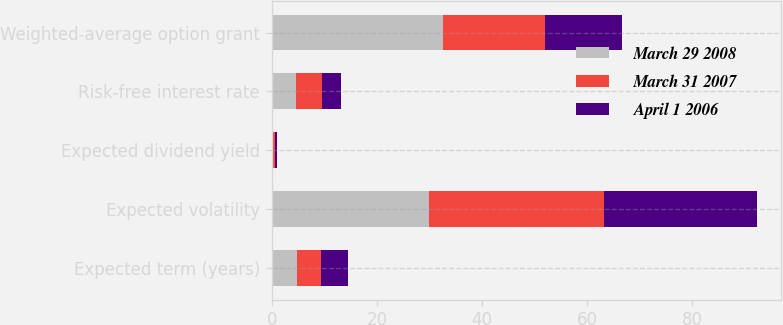Convert chart. <chart><loc_0><loc_0><loc_500><loc_500><stacked_bar_chart><ecel><fcel>Expected term (years)<fcel>Expected volatility<fcel>Expected dividend yield<fcel>Risk-free interest rate<fcel>Weighted-average option grant<nl><fcel>March 29 2008<fcel>4.8<fcel>29.9<fcel>0.26<fcel>4.6<fcel>32.65<nl><fcel>March 31 2007<fcel>4.5<fcel>33.2<fcel>0.39<fcel>4.9<fcel>19.4<nl><fcel>April 1 2006<fcel>5.2<fcel>29.1<fcel>0.45<fcel>3.7<fcel>14.5<nl></chart> 